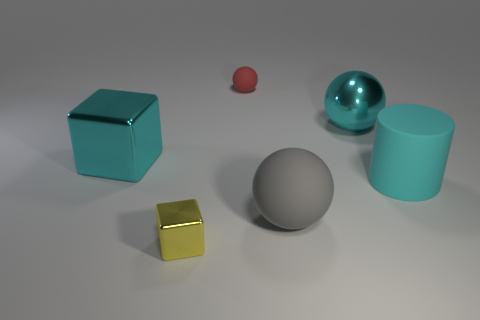There is a large ball behind the big sphere that is left of the cyan shiny object that is to the right of the tiny cube; what color is it?
Make the answer very short. Cyan. Are there more tiny yellow shiny objects that are in front of the large cube than tiny rubber spheres in front of the cyan sphere?
Make the answer very short. Yes. How many other objects are the same size as the gray rubber sphere?
Offer a very short reply. 3. What is the size of the rubber cylinder that is the same color as the big metal sphere?
Your answer should be compact. Large. The ball on the left side of the large matte thing that is to the left of the large cylinder is made of what material?
Your answer should be compact. Rubber. Are there any tiny blocks to the left of the small red object?
Provide a short and direct response. Yes. Is the number of large gray things to the right of the large shiny block greater than the number of big brown shiny cylinders?
Your answer should be compact. Yes. Is there a ball that has the same color as the large cylinder?
Your response must be concise. Yes. There is a rubber ball that is the same size as the cyan block; what color is it?
Ensure brevity in your answer.  Gray. There is a metal cube that is in front of the rubber cylinder; is there a shiny object that is to the right of it?
Your answer should be very brief. Yes. 